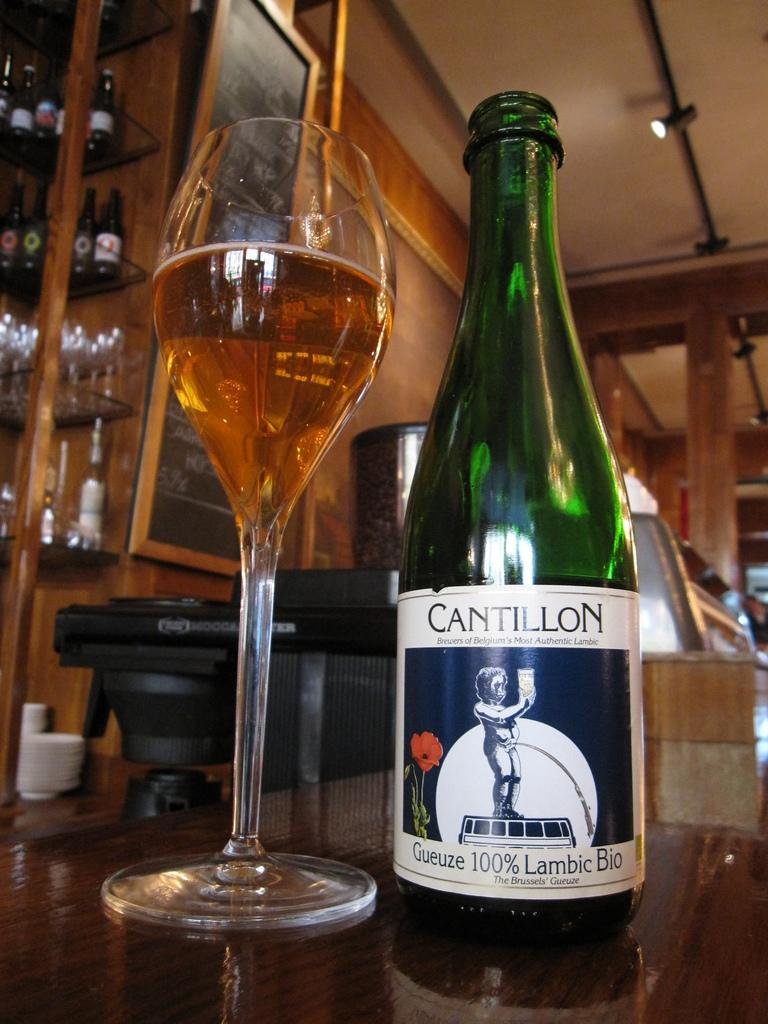What objects are on the table in the image? There is a bottle and a glass on the table in the image. What is the purpose of the bottle and the glass? The bottle and the glass are likely used for holding or serving a beverage. What can be seen in the background of the image? There are other glasses on a rack and a wooden cupboard in the background. How many legs does the family have in the image? There is no family present in the image, so it is not possible to determine the number of legs they might have. 